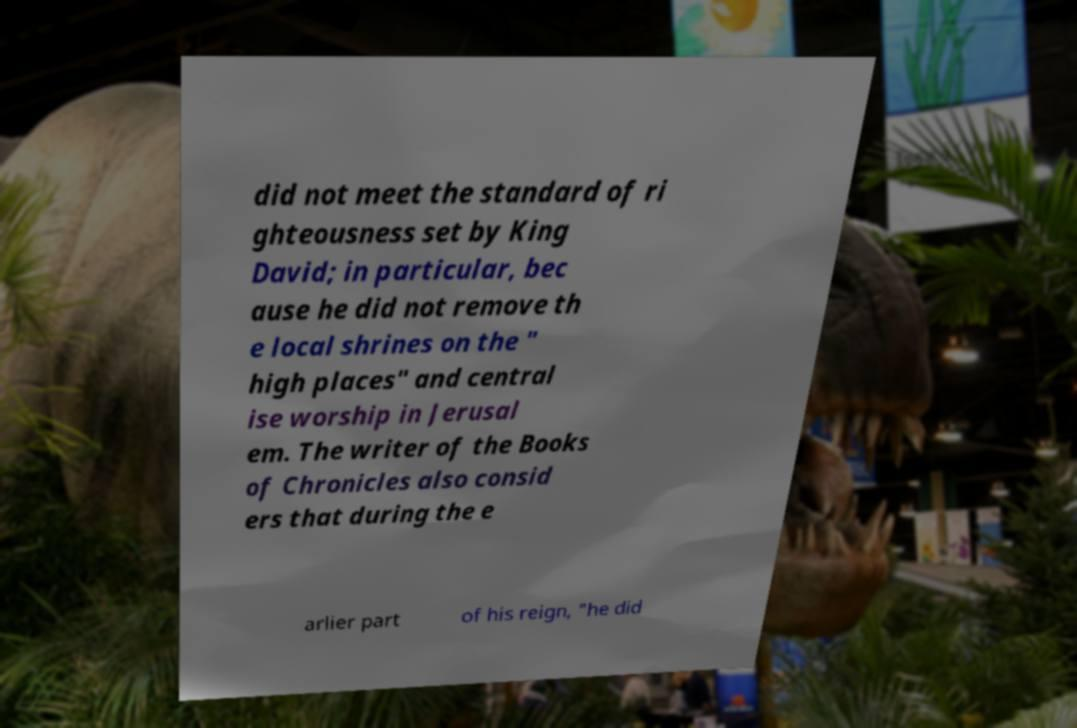What messages or text are displayed in this image? I need them in a readable, typed format. did not meet the standard of ri ghteousness set by King David; in particular, bec ause he did not remove th e local shrines on the " high places" and central ise worship in Jerusal em. The writer of the Books of Chronicles also consid ers that during the e arlier part of his reign, "he did 